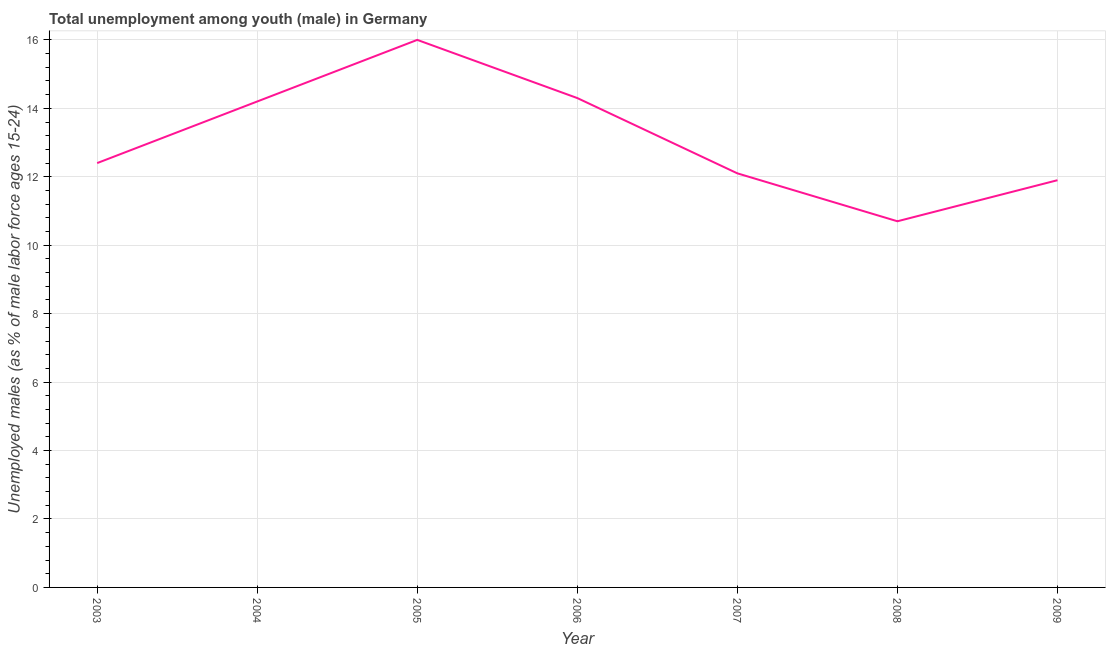What is the unemployed male youth population in 2004?
Your answer should be compact. 14.2. Across all years, what is the minimum unemployed male youth population?
Ensure brevity in your answer.  10.7. In which year was the unemployed male youth population minimum?
Provide a succinct answer. 2008. What is the sum of the unemployed male youth population?
Your answer should be very brief. 91.6. What is the difference between the unemployed male youth population in 2003 and 2005?
Keep it short and to the point. -3.6. What is the average unemployed male youth population per year?
Your answer should be very brief. 13.09. What is the median unemployed male youth population?
Your answer should be very brief. 12.4. Do a majority of the years between 2006 and 2008 (inclusive) have unemployed male youth population greater than 8.8 %?
Keep it short and to the point. Yes. What is the ratio of the unemployed male youth population in 2006 to that in 2007?
Give a very brief answer. 1.18. Is the unemployed male youth population in 2004 less than that in 2007?
Give a very brief answer. No. What is the difference between the highest and the second highest unemployed male youth population?
Offer a very short reply. 1.7. Is the sum of the unemployed male youth population in 2007 and 2009 greater than the maximum unemployed male youth population across all years?
Your answer should be very brief. Yes. What is the difference between the highest and the lowest unemployed male youth population?
Ensure brevity in your answer.  5.3. Does the unemployed male youth population monotonically increase over the years?
Ensure brevity in your answer.  No. How many years are there in the graph?
Offer a very short reply. 7. Are the values on the major ticks of Y-axis written in scientific E-notation?
Offer a terse response. No. Does the graph contain any zero values?
Offer a terse response. No. What is the title of the graph?
Give a very brief answer. Total unemployment among youth (male) in Germany. What is the label or title of the Y-axis?
Give a very brief answer. Unemployed males (as % of male labor force ages 15-24). What is the Unemployed males (as % of male labor force ages 15-24) in 2003?
Provide a succinct answer. 12.4. What is the Unemployed males (as % of male labor force ages 15-24) of 2004?
Provide a short and direct response. 14.2. What is the Unemployed males (as % of male labor force ages 15-24) in 2006?
Provide a succinct answer. 14.3. What is the Unemployed males (as % of male labor force ages 15-24) in 2007?
Give a very brief answer. 12.1. What is the Unemployed males (as % of male labor force ages 15-24) of 2008?
Your answer should be compact. 10.7. What is the Unemployed males (as % of male labor force ages 15-24) in 2009?
Offer a terse response. 11.9. What is the difference between the Unemployed males (as % of male labor force ages 15-24) in 2003 and 2005?
Keep it short and to the point. -3.6. What is the difference between the Unemployed males (as % of male labor force ages 15-24) in 2003 and 2006?
Your answer should be very brief. -1.9. What is the difference between the Unemployed males (as % of male labor force ages 15-24) in 2003 and 2009?
Make the answer very short. 0.5. What is the difference between the Unemployed males (as % of male labor force ages 15-24) in 2004 and 2005?
Keep it short and to the point. -1.8. What is the difference between the Unemployed males (as % of male labor force ages 15-24) in 2004 and 2007?
Your answer should be very brief. 2.1. What is the difference between the Unemployed males (as % of male labor force ages 15-24) in 2004 and 2009?
Offer a very short reply. 2.3. What is the difference between the Unemployed males (as % of male labor force ages 15-24) in 2005 and 2007?
Provide a short and direct response. 3.9. What is the ratio of the Unemployed males (as % of male labor force ages 15-24) in 2003 to that in 2004?
Offer a terse response. 0.87. What is the ratio of the Unemployed males (as % of male labor force ages 15-24) in 2003 to that in 2005?
Give a very brief answer. 0.78. What is the ratio of the Unemployed males (as % of male labor force ages 15-24) in 2003 to that in 2006?
Your answer should be compact. 0.87. What is the ratio of the Unemployed males (as % of male labor force ages 15-24) in 2003 to that in 2008?
Give a very brief answer. 1.16. What is the ratio of the Unemployed males (as % of male labor force ages 15-24) in 2003 to that in 2009?
Provide a short and direct response. 1.04. What is the ratio of the Unemployed males (as % of male labor force ages 15-24) in 2004 to that in 2005?
Ensure brevity in your answer.  0.89. What is the ratio of the Unemployed males (as % of male labor force ages 15-24) in 2004 to that in 2007?
Your response must be concise. 1.17. What is the ratio of the Unemployed males (as % of male labor force ages 15-24) in 2004 to that in 2008?
Offer a very short reply. 1.33. What is the ratio of the Unemployed males (as % of male labor force ages 15-24) in 2004 to that in 2009?
Provide a short and direct response. 1.19. What is the ratio of the Unemployed males (as % of male labor force ages 15-24) in 2005 to that in 2006?
Give a very brief answer. 1.12. What is the ratio of the Unemployed males (as % of male labor force ages 15-24) in 2005 to that in 2007?
Give a very brief answer. 1.32. What is the ratio of the Unemployed males (as % of male labor force ages 15-24) in 2005 to that in 2008?
Your answer should be compact. 1.5. What is the ratio of the Unemployed males (as % of male labor force ages 15-24) in 2005 to that in 2009?
Your answer should be very brief. 1.34. What is the ratio of the Unemployed males (as % of male labor force ages 15-24) in 2006 to that in 2007?
Your answer should be very brief. 1.18. What is the ratio of the Unemployed males (as % of male labor force ages 15-24) in 2006 to that in 2008?
Your answer should be compact. 1.34. What is the ratio of the Unemployed males (as % of male labor force ages 15-24) in 2006 to that in 2009?
Offer a terse response. 1.2. What is the ratio of the Unemployed males (as % of male labor force ages 15-24) in 2007 to that in 2008?
Offer a very short reply. 1.13. What is the ratio of the Unemployed males (as % of male labor force ages 15-24) in 2007 to that in 2009?
Provide a short and direct response. 1.02. What is the ratio of the Unemployed males (as % of male labor force ages 15-24) in 2008 to that in 2009?
Ensure brevity in your answer.  0.9. 